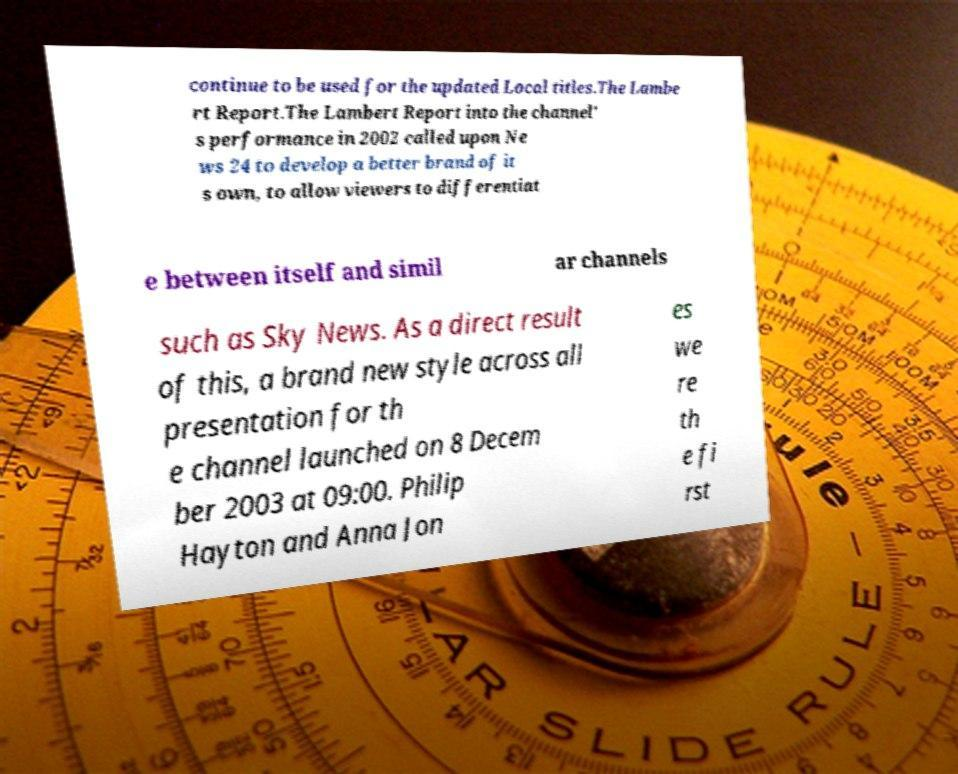Please read and relay the text visible in this image. What does it say? continue to be used for the updated Local titles.The Lambe rt Report.The Lambert Report into the channel' s performance in 2002 called upon Ne ws 24 to develop a better brand of it s own, to allow viewers to differentiat e between itself and simil ar channels such as Sky News. As a direct result of this, a brand new style across all presentation for th e channel launched on 8 Decem ber 2003 at 09:00. Philip Hayton and Anna Jon es we re th e fi rst 